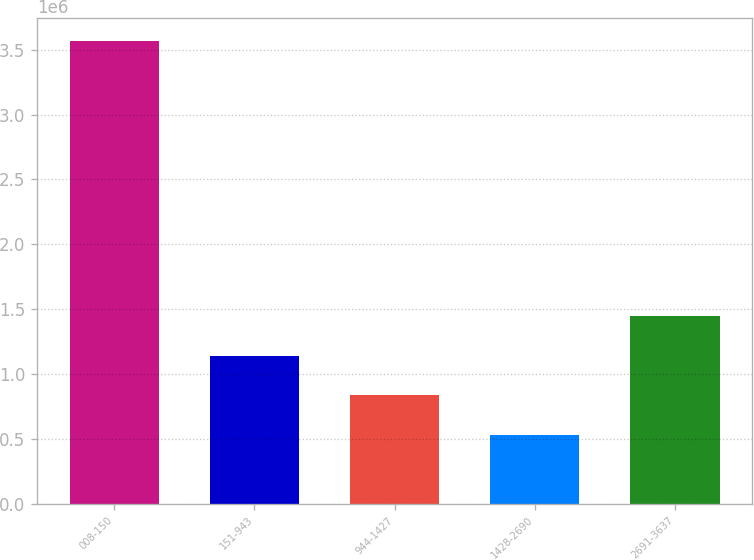<chart> <loc_0><loc_0><loc_500><loc_500><bar_chart><fcel>008-150<fcel>151-943<fcel>944-1427<fcel>1428-2690<fcel>2691-3637<nl><fcel>3.57018e+06<fcel>1.14005e+06<fcel>836285<fcel>532519<fcel>1.44382e+06<nl></chart> 